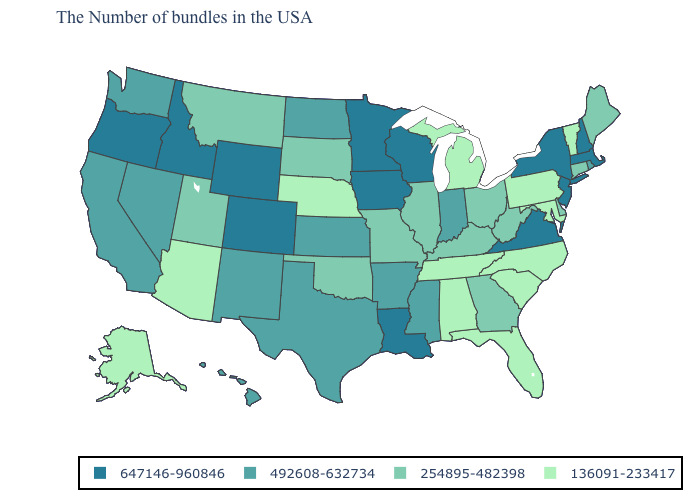Which states have the highest value in the USA?
Quick response, please. Massachusetts, New Hampshire, New York, New Jersey, Virginia, Wisconsin, Louisiana, Minnesota, Iowa, Wyoming, Colorado, Idaho, Oregon. What is the value of Nevada?
Give a very brief answer. 492608-632734. Is the legend a continuous bar?
Short answer required. No. Among the states that border Arizona , does Nevada have the highest value?
Keep it brief. No. Name the states that have a value in the range 254895-482398?
Give a very brief answer. Maine, Connecticut, Delaware, West Virginia, Ohio, Georgia, Kentucky, Illinois, Missouri, Oklahoma, South Dakota, Utah, Montana. Does the first symbol in the legend represent the smallest category?
Concise answer only. No. Which states have the lowest value in the USA?
Answer briefly. Vermont, Maryland, Pennsylvania, North Carolina, South Carolina, Florida, Michigan, Alabama, Tennessee, Nebraska, Arizona, Alaska. Name the states that have a value in the range 647146-960846?
Be succinct. Massachusetts, New Hampshire, New York, New Jersey, Virginia, Wisconsin, Louisiana, Minnesota, Iowa, Wyoming, Colorado, Idaho, Oregon. Does New York have the highest value in the USA?
Concise answer only. Yes. Among the states that border Pennsylvania , does Ohio have the highest value?
Answer briefly. No. Name the states that have a value in the range 492608-632734?
Short answer required. Rhode Island, Indiana, Mississippi, Arkansas, Kansas, Texas, North Dakota, New Mexico, Nevada, California, Washington, Hawaii. What is the lowest value in the MidWest?
Keep it brief. 136091-233417. Name the states that have a value in the range 136091-233417?
Short answer required. Vermont, Maryland, Pennsylvania, North Carolina, South Carolina, Florida, Michigan, Alabama, Tennessee, Nebraska, Arizona, Alaska. Is the legend a continuous bar?
Write a very short answer. No. 